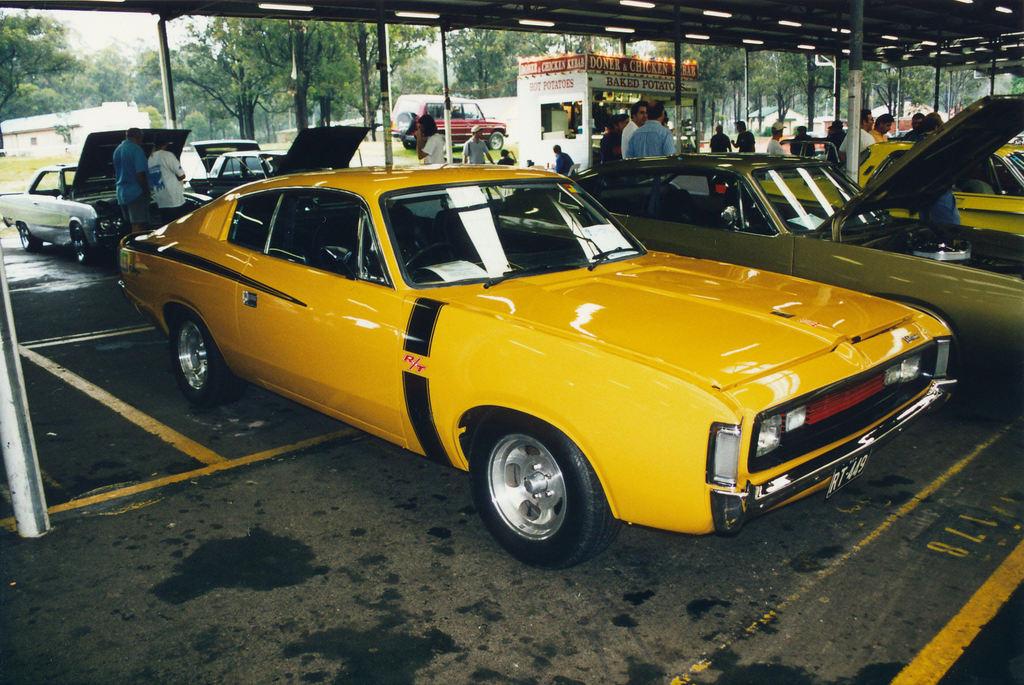What parking spot is the yellow car in?
Keep it short and to the point. 178. What is the snack shop selling?
Offer a terse response. Baked potatoes. 